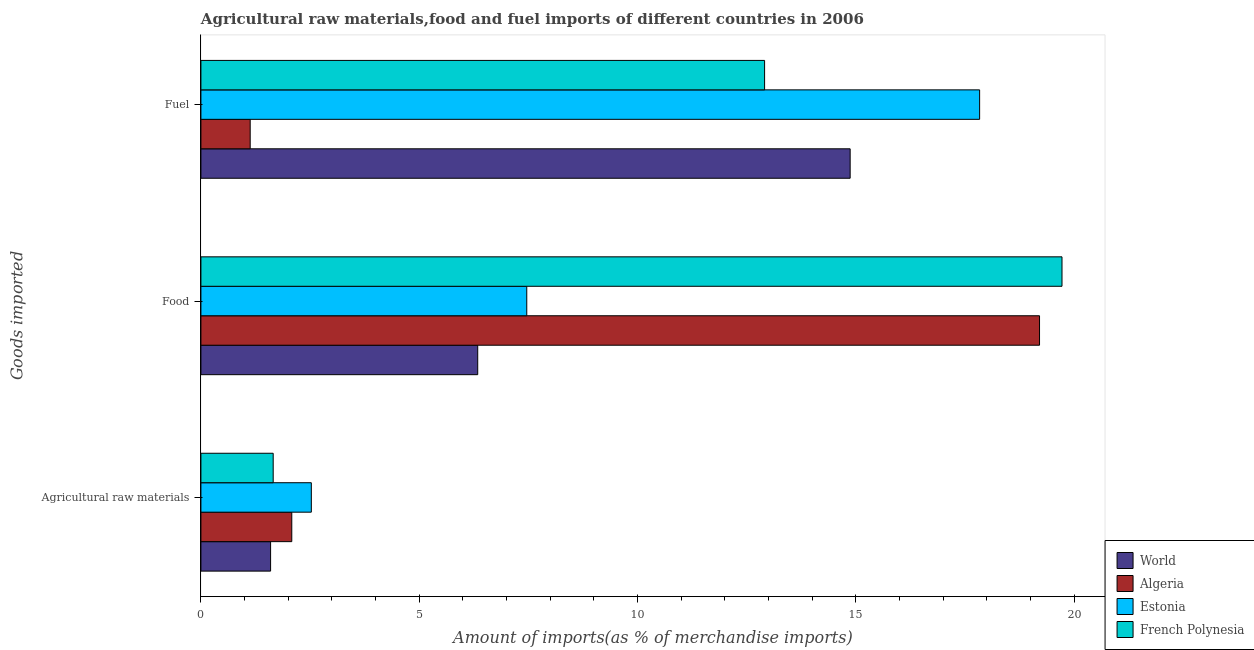How many different coloured bars are there?
Your response must be concise. 4. How many groups of bars are there?
Offer a terse response. 3. Are the number of bars per tick equal to the number of legend labels?
Your answer should be compact. Yes. Are the number of bars on each tick of the Y-axis equal?
Make the answer very short. Yes. What is the label of the 3rd group of bars from the top?
Make the answer very short. Agricultural raw materials. What is the percentage of raw materials imports in World?
Your answer should be very brief. 1.6. Across all countries, what is the maximum percentage of food imports?
Provide a succinct answer. 19.72. Across all countries, what is the minimum percentage of food imports?
Your response must be concise. 6.34. In which country was the percentage of raw materials imports maximum?
Offer a very short reply. Estonia. What is the total percentage of food imports in the graph?
Give a very brief answer. 52.72. What is the difference between the percentage of fuel imports in Algeria and that in French Polynesia?
Your response must be concise. -11.78. What is the difference between the percentage of fuel imports in World and the percentage of food imports in Algeria?
Provide a short and direct response. -4.34. What is the average percentage of food imports per country?
Keep it short and to the point. 13.18. What is the difference between the percentage of fuel imports and percentage of raw materials imports in French Polynesia?
Give a very brief answer. 11.25. In how many countries, is the percentage of food imports greater than 9 %?
Keep it short and to the point. 2. What is the ratio of the percentage of fuel imports in French Polynesia to that in World?
Provide a short and direct response. 0.87. What is the difference between the highest and the second highest percentage of fuel imports?
Your answer should be compact. 2.96. What is the difference between the highest and the lowest percentage of food imports?
Provide a succinct answer. 13.38. What does the 3rd bar from the top in Food represents?
Your answer should be compact. Algeria. What does the 3rd bar from the bottom in Fuel represents?
Provide a short and direct response. Estonia. Is it the case that in every country, the sum of the percentage of raw materials imports and percentage of food imports is greater than the percentage of fuel imports?
Provide a short and direct response. No. How many bars are there?
Make the answer very short. 12. Are all the bars in the graph horizontal?
Give a very brief answer. Yes. How many countries are there in the graph?
Ensure brevity in your answer.  4. Are the values on the major ticks of X-axis written in scientific E-notation?
Offer a very short reply. No. Does the graph contain any zero values?
Your answer should be very brief. No. Where does the legend appear in the graph?
Provide a short and direct response. Bottom right. How many legend labels are there?
Your answer should be compact. 4. How are the legend labels stacked?
Your response must be concise. Vertical. What is the title of the graph?
Ensure brevity in your answer.  Agricultural raw materials,food and fuel imports of different countries in 2006. What is the label or title of the X-axis?
Give a very brief answer. Amount of imports(as % of merchandise imports). What is the label or title of the Y-axis?
Give a very brief answer. Goods imported. What is the Amount of imports(as % of merchandise imports) in World in Agricultural raw materials?
Your answer should be compact. 1.6. What is the Amount of imports(as % of merchandise imports) of Algeria in Agricultural raw materials?
Your answer should be very brief. 2.08. What is the Amount of imports(as % of merchandise imports) of Estonia in Agricultural raw materials?
Keep it short and to the point. 2.53. What is the Amount of imports(as % of merchandise imports) of French Polynesia in Agricultural raw materials?
Offer a very short reply. 1.66. What is the Amount of imports(as % of merchandise imports) in World in Food?
Your answer should be compact. 6.34. What is the Amount of imports(as % of merchandise imports) in Algeria in Food?
Provide a short and direct response. 19.2. What is the Amount of imports(as % of merchandise imports) of Estonia in Food?
Your response must be concise. 7.46. What is the Amount of imports(as % of merchandise imports) in French Polynesia in Food?
Your response must be concise. 19.72. What is the Amount of imports(as % of merchandise imports) of World in Fuel?
Make the answer very short. 14.87. What is the Amount of imports(as % of merchandise imports) of Algeria in Fuel?
Keep it short and to the point. 1.13. What is the Amount of imports(as % of merchandise imports) of Estonia in Fuel?
Offer a terse response. 17.83. What is the Amount of imports(as % of merchandise imports) in French Polynesia in Fuel?
Keep it short and to the point. 12.91. Across all Goods imported, what is the maximum Amount of imports(as % of merchandise imports) of World?
Your answer should be very brief. 14.87. Across all Goods imported, what is the maximum Amount of imports(as % of merchandise imports) of Algeria?
Offer a very short reply. 19.2. Across all Goods imported, what is the maximum Amount of imports(as % of merchandise imports) of Estonia?
Make the answer very short. 17.83. Across all Goods imported, what is the maximum Amount of imports(as % of merchandise imports) of French Polynesia?
Your answer should be very brief. 19.72. Across all Goods imported, what is the minimum Amount of imports(as % of merchandise imports) in World?
Keep it short and to the point. 1.6. Across all Goods imported, what is the minimum Amount of imports(as % of merchandise imports) of Algeria?
Your answer should be very brief. 1.13. Across all Goods imported, what is the minimum Amount of imports(as % of merchandise imports) of Estonia?
Keep it short and to the point. 2.53. Across all Goods imported, what is the minimum Amount of imports(as % of merchandise imports) in French Polynesia?
Make the answer very short. 1.66. What is the total Amount of imports(as % of merchandise imports) in World in the graph?
Provide a short and direct response. 22.8. What is the total Amount of imports(as % of merchandise imports) in Algeria in the graph?
Offer a very short reply. 22.41. What is the total Amount of imports(as % of merchandise imports) in Estonia in the graph?
Give a very brief answer. 27.82. What is the total Amount of imports(as % of merchandise imports) of French Polynesia in the graph?
Ensure brevity in your answer.  34.28. What is the difference between the Amount of imports(as % of merchandise imports) of World in Agricultural raw materials and that in Food?
Ensure brevity in your answer.  -4.74. What is the difference between the Amount of imports(as % of merchandise imports) of Algeria in Agricultural raw materials and that in Food?
Make the answer very short. -17.12. What is the difference between the Amount of imports(as % of merchandise imports) in Estonia in Agricultural raw materials and that in Food?
Offer a terse response. -4.93. What is the difference between the Amount of imports(as % of merchandise imports) of French Polynesia in Agricultural raw materials and that in Food?
Keep it short and to the point. -18.06. What is the difference between the Amount of imports(as % of merchandise imports) of World in Agricultural raw materials and that in Fuel?
Provide a short and direct response. -13.27. What is the difference between the Amount of imports(as % of merchandise imports) in Algeria in Agricultural raw materials and that in Fuel?
Provide a short and direct response. 0.95. What is the difference between the Amount of imports(as % of merchandise imports) of Estonia in Agricultural raw materials and that in Fuel?
Provide a short and direct response. -15.3. What is the difference between the Amount of imports(as % of merchandise imports) in French Polynesia in Agricultural raw materials and that in Fuel?
Your answer should be very brief. -11.25. What is the difference between the Amount of imports(as % of merchandise imports) of World in Food and that in Fuel?
Offer a very short reply. -8.53. What is the difference between the Amount of imports(as % of merchandise imports) in Algeria in Food and that in Fuel?
Give a very brief answer. 18.08. What is the difference between the Amount of imports(as % of merchandise imports) of Estonia in Food and that in Fuel?
Your answer should be compact. -10.37. What is the difference between the Amount of imports(as % of merchandise imports) in French Polynesia in Food and that in Fuel?
Make the answer very short. 6.81. What is the difference between the Amount of imports(as % of merchandise imports) in World in Agricultural raw materials and the Amount of imports(as % of merchandise imports) in Algeria in Food?
Ensure brevity in your answer.  -17.61. What is the difference between the Amount of imports(as % of merchandise imports) in World in Agricultural raw materials and the Amount of imports(as % of merchandise imports) in Estonia in Food?
Your answer should be compact. -5.87. What is the difference between the Amount of imports(as % of merchandise imports) in World in Agricultural raw materials and the Amount of imports(as % of merchandise imports) in French Polynesia in Food?
Keep it short and to the point. -18.12. What is the difference between the Amount of imports(as % of merchandise imports) in Algeria in Agricultural raw materials and the Amount of imports(as % of merchandise imports) in Estonia in Food?
Offer a very short reply. -5.38. What is the difference between the Amount of imports(as % of merchandise imports) in Algeria in Agricultural raw materials and the Amount of imports(as % of merchandise imports) in French Polynesia in Food?
Provide a short and direct response. -17.64. What is the difference between the Amount of imports(as % of merchandise imports) in Estonia in Agricultural raw materials and the Amount of imports(as % of merchandise imports) in French Polynesia in Food?
Your response must be concise. -17.19. What is the difference between the Amount of imports(as % of merchandise imports) of World in Agricultural raw materials and the Amount of imports(as % of merchandise imports) of Algeria in Fuel?
Give a very brief answer. 0.47. What is the difference between the Amount of imports(as % of merchandise imports) in World in Agricultural raw materials and the Amount of imports(as % of merchandise imports) in Estonia in Fuel?
Your answer should be compact. -16.24. What is the difference between the Amount of imports(as % of merchandise imports) of World in Agricultural raw materials and the Amount of imports(as % of merchandise imports) of French Polynesia in Fuel?
Make the answer very short. -11.31. What is the difference between the Amount of imports(as % of merchandise imports) in Algeria in Agricultural raw materials and the Amount of imports(as % of merchandise imports) in Estonia in Fuel?
Your response must be concise. -15.75. What is the difference between the Amount of imports(as % of merchandise imports) of Algeria in Agricultural raw materials and the Amount of imports(as % of merchandise imports) of French Polynesia in Fuel?
Provide a short and direct response. -10.83. What is the difference between the Amount of imports(as % of merchandise imports) in Estonia in Agricultural raw materials and the Amount of imports(as % of merchandise imports) in French Polynesia in Fuel?
Offer a terse response. -10.38. What is the difference between the Amount of imports(as % of merchandise imports) of World in Food and the Amount of imports(as % of merchandise imports) of Algeria in Fuel?
Keep it short and to the point. 5.21. What is the difference between the Amount of imports(as % of merchandise imports) of World in Food and the Amount of imports(as % of merchandise imports) of Estonia in Fuel?
Ensure brevity in your answer.  -11.49. What is the difference between the Amount of imports(as % of merchandise imports) of World in Food and the Amount of imports(as % of merchandise imports) of French Polynesia in Fuel?
Your answer should be compact. -6.57. What is the difference between the Amount of imports(as % of merchandise imports) in Algeria in Food and the Amount of imports(as % of merchandise imports) in Estonia in Fuel?
Provide a short and direct response. 1.37. What is the difference between the Amount of imports(as % of merchandise imports) of Algeria in Food and the Amount of imports(as % of merchandise imports) of French Polynesia in Fuel?
Your answer should be compact. 6.3. What is the difference between the Amount of imports(as % of merchandise imports) in Estonia in Food and the Amount of imports(as % of merchandise imports) in French Polynesia in Fuel?
Ensure brevity in your answer.  -5.45. What is the average Amount of imports(as % of merchandise imports) of World per Goods imported?
Offer a very short reply. 7.6. What is the average Amount of imports(as % of merchandise imports) of Algeria per Goods imported?
Your answer should be compact. 7.47. What is the average Amount of imports(as % of merchandise imports) in Estonia per Goods imported?
Provide a short and direct response. 9.27. What is the average Amount of imports(as % of merchandise imports) of French Polynesia per Goods imported?
Your answer should be compact. 11.43. What is the difference between the Amount of imports(as % of merchandise imports) in World and Amount of imports(as % of merchandise imports) in Algeria in Agricultural raw materials?
Your response must be concise. -0.49. What is the difference between the Amount of imports(as % of merchandise imports) of World and Amount of imports(as % of merchandise imports) of Estonia in Agricultural raw materials?
Make the answer very short. -0.93. What is the difference between the Amount of imports(as % of merchandise imports) in World and Amount of imports(as % of merchandise imports) in French Polynesia in Agricultural raw materials?
Your answer should be very brief. -0.06. What is the difference between the Amount of imports(as % of merchandise imports) of Algeria and Amount of imports(as % of merchandise imports) of Estonia in Agricultural raw materials?
Give a very brief answer. -0.45. What is the difference between the Amount of imports(as % of merchandise imports) in Algeria and Amount of imports(as % of merchandise imports) in French Polynesia in Agricultural raw materials?
Your answer should be very brief. 0.43. What is the difference between the Amount of imports(as % of merchandise imports) in Estonia and Amount of imports(as % of merchandise imports) in French Polynesia in Agricultural raw materials?
Give a very brief answer. 0.87. What is the difference between the Amount of imports(as % of merchandise imports) in World and Amount of imports(as % of merchandise imports) in Algeria in Food?
Provide a succinct answer. -12.87. What is the difference between the Amount of imports(as % of merchandise imports) in World and Amount of imports(as % of merchandise imports) in Estonia in Food?
Offer a very short reply. -1.12. What is the difference between the Amount of imports(as % of merchandise imports) of World and Amount of imports(as % of merchandise imports) of French Polynesia in Food?
Keep it short and to the point. -13.38. What is the difference between the Amount of imports(as % of merchandise imports) in Algeria and Amount of imports(as % of merchandise imports) in Estonia in Food?
Offer a terse response. 11.74. What is the difference between the Amount of imports(as % of merchandise imports) of Algeria and Amount of imports(as % of merchandise imports) of French Polynesia in Food?
Offer a very short reply. -0.51. What is the difference between the Amount of imports(as % of merchandise imports) in Estonia and Amount of imports(as % of merchandise imports) in French Polynesia in Food?
Offer a terse response. -12.26. What is the difference between the Amount of imports(as % of merchandise imports) in World and Amount of imports(as % of merchandise imports) in Algeria in Fuel?
Your answer should be compact. 13.74. What is the difference between the Amount of imports(as % of merchandise imports) of World and Amount of imports(as % of merchandise imports) of Estonia in Fuel?
Offer a terse response. -2.96. What is the difference between the Amount of imports(as % of merchandise imports) of World and Amount of imports(as % of merchandise imports) of French Polynesia in Fuel?
Your response must be concise. 1.96. What is the difference between the Amount of imports(as % of merchandise imports) in Algeria and Amount of imports(as % of merchandise imports) in Estonia in Fuel?
Give a very brief answer. -16.7. What is the difference between the Amount of imports(as % of merchandise imports) in Algeria and Amount of imports(as % of merchandise imports) in French Polynesia in Fuel?
Keep it short and to the point. -11.78. What is the difference between the Amount of imports(as % of merchandise imports) of Estonia and Amount of imports(as % of merchandise imports) of French Polynesia in Fuel?
Offer a terse response. 4.92. What is the ratio of the Amount of imports(as % of merchandise imports) of World in Agricultural raw materials to that in Food?
Provide a short and direct response. 0.25. What is the ratio of the Amount of imports(as % of merchandise imports) of Algeria in Agricultural raw materials to that in Food?
Your answer should be very brief. 0.11. What is the ratio of the Amount of imports(as % of merchandise imports) of Estonia in Agricultural raw materials to that in Food?
Offer a terse response. 0.34. What is the ratio of the Amount of imports(as % of merchandise imports) in French Polynesia in Agricultural raw materials to that in Food?
Ensure brevity in your answer.  0.08. What is the ratio of the Amount of imports(as % of merchandise imports) of World in Agricultural raw materials to that in Fuel?
Ensure brevity in your answer.  0.11. What is the ratio of the Amount of imports(as % of merchandise imports) of Algeria in Agricultural raw materials to that in Fuel?
Your answer should be very brief. 1.84. What is the ratio of the Amount of imports(as % of merchandise imports) of Estonia in Agricultural raw materials to that in Fuel?
Your response must be concise. 0.14. What is the ratio of the Amount of imports(as % of merchandise imports) in French Polynesia in Agricultural raw materials to that in Fuel?
Offer a very short reply. 0.13. What is the ratio of the Amount of imports(as % of merchandise imports) in World in Food to that in Fuel?
Provide a short and direct response. 0.43. What is the ratio of the Amount of imports(as % of merchandise imports) of Algeria in Food to that in Fuel?
Your answer should be compact. 17.02. What is the ratio of the Amount of imports(as % of merchandise imports) in Estonia in Food to that in Fuel?
Ensure brevity in your answer.  0.42. What is the ratio of the Amount of imports(as % of merchandise imports) of French Polynesia in Food to that in Fuel?
Offer a terse response. 1.53. What is the difference between the highest and the second highest Amount of imports(as % of merchandise imports) in World?
Keep it short and to the point. 8.53. What is the difference between the highest and the second highest Amount of imports(as % of merchandise imports) of Algeria?
Offer a terse response. 17.12. What is the difference between the highest and the second highest Amount of imports(as % of merchandise imports) in Estonia?
Provide a short and direct response. 10.37. What is the difference between the highest and the second highest Amount of imports(as % of merchandise imports) in French Polynesia?
Ensure brevity in your answer.  6.81. What is the difference between the highest and the lowest Amount of imports(as % of merchandise imports) in World?
Your answer should be compact. 13.27. What is the difference between the highest and the lowest Amount of imports(as % of merchandise imports) of Algeria?
Keep it short and to the point. 18.08. What is the difference between the highest and the lowest Amount of imports(as % of merchandise imports) of Estonia?
Give a very brief answer. 15.3. What is the difference between the highest and the lowest Amount of imports(as % of merchandise imports) in French Polynesia?
Offer a very short reply. 18.06. 